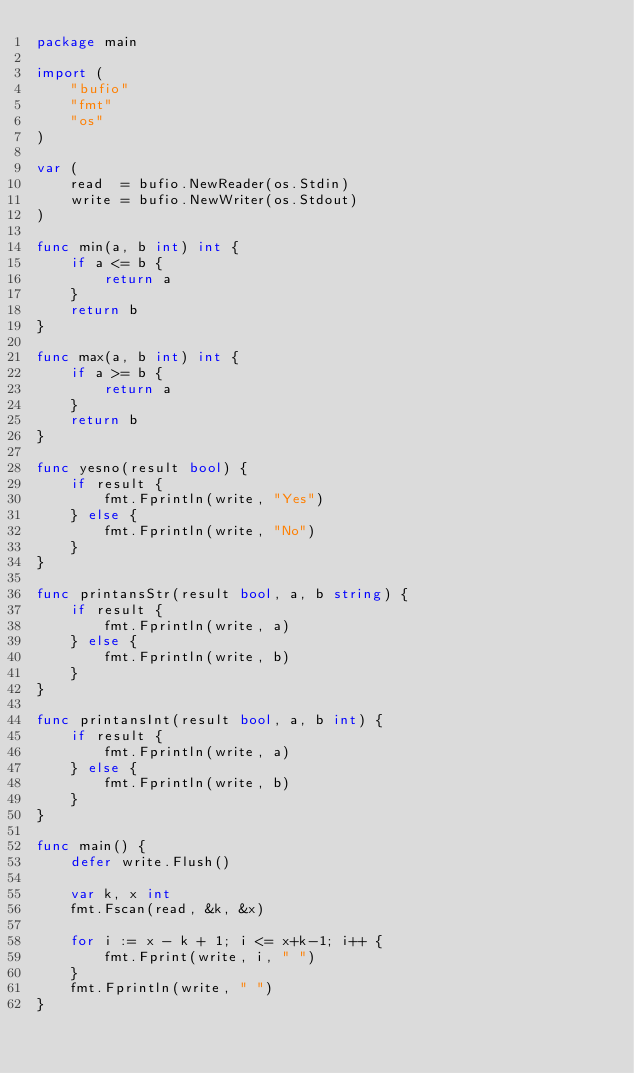Convert code to text. <code><loc_0><loc_0><loc_500><loc_500><_Go_>package main

import (
	"bufio"
	"fmt"
	"os"
)

var (
	read  = bufio.NewReader(os.Stdin)
	write = bufio.NewWriter(os.Stdout)
)

func min(a, b int) int {
	if a <= b {
		return a
	}
	return b
}

func max(a, b int) int {
	if a >= b {
		return a
	}
	return b
}

func yesno(result bool) {
	if result {
		fmt.Fprintln(write, "Yes")
	} else {
		fmt.Fprintln(write, "No")
	}
}

func printansStr(result bool, a, b string) {
	if result {
		fmt.Fprintln(write, a)
	} else {
		fmt.Fprintln(write, b)
	}
}

func printansInt(result bool, a, b int) {
	if result {
		fmt.Fprintln(write, a)
	} else {
		fmt.Fprintln(write, b)
	}
}

func main() {
	defer write.Flush()

	var k, x int
	fmt.Fscan(read, &k, &x)

	for i := x - k + 1; i <= x+k-1; i++ {
		fmt.Fprint(write, i, " ")
	}
	fmt.Fprintln(write, " ")
}
</code> 